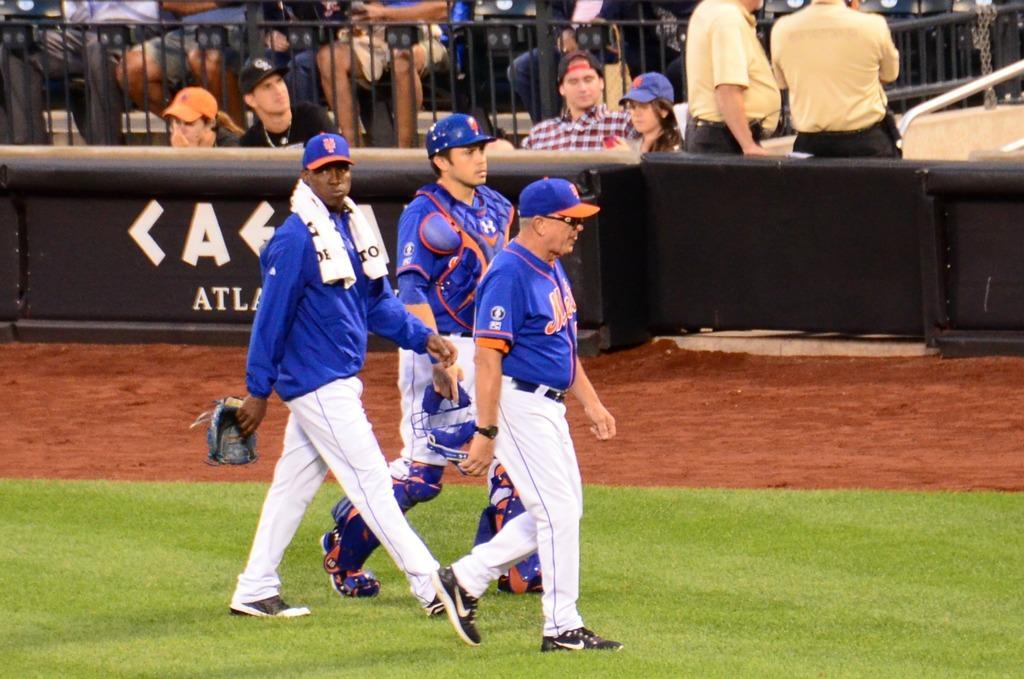How would you summarize this image in a sentence or two? In this picture we can see three men walking here, at the bottom there is grass, these three persons wore caps and shoes, in the background there are some people sitting, we can see barricade here. 